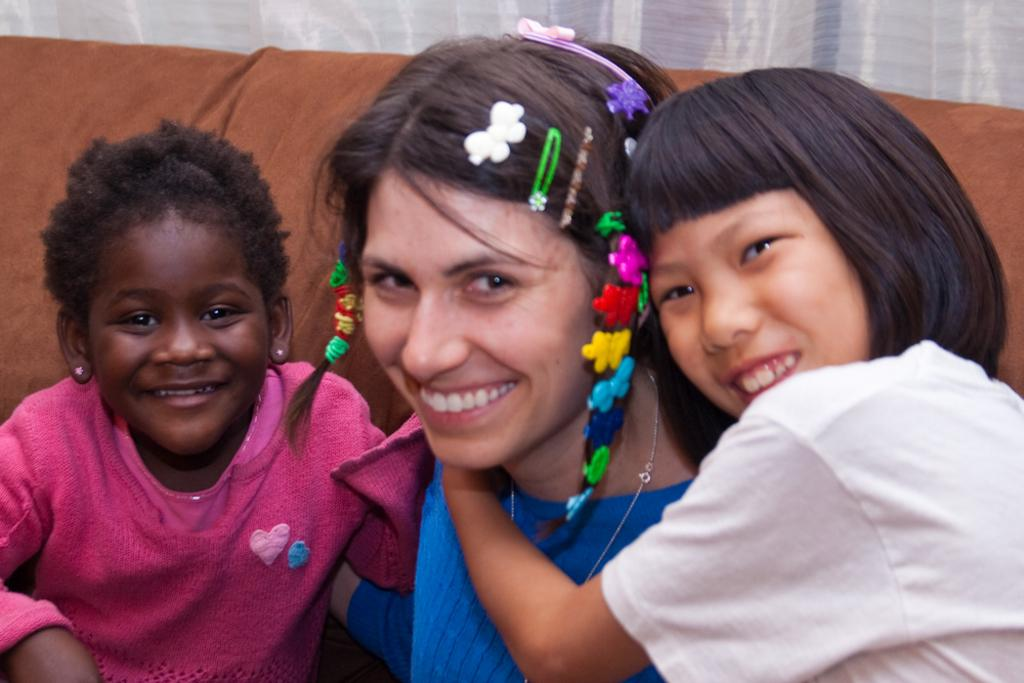How many people are in the image? There are three people in the image. Can you describe the individuals in the image? There are two children and a woman in the image. Where are the two children and the woman located? The two children and the woman are on a sofa. What type of gate can be seen in the image? There is no gate present in the image. What kind of loaf is being prepared by the woman in the image? There is no loaf or any indication of food preparation in the image. 